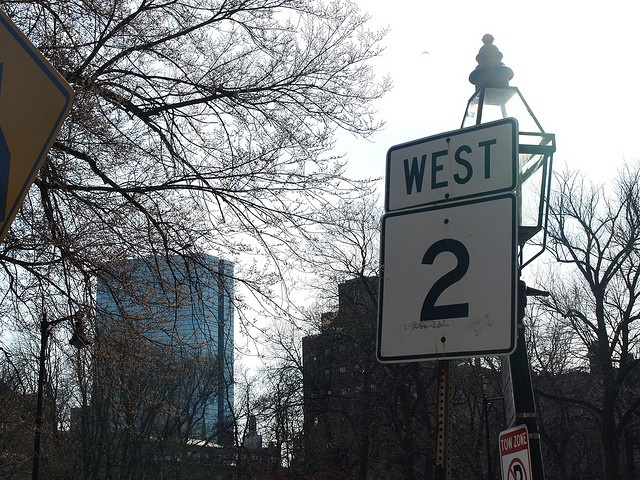Describe the objects in this image and their specific colors. I can see various objects in this image with different colors. 